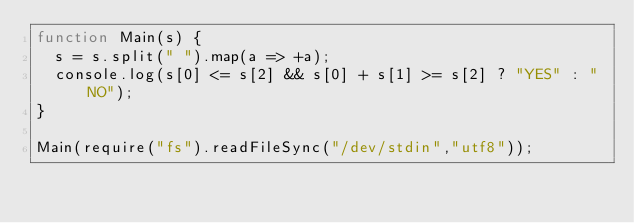<code> <loc_0><loc_0><loc_500><loc_500><_JavaScript_>function Main(s) {
  s = s.split(" ").map(a => +a);
  console.log(s[0] <= s[2] && s[0] + s[1] >= s[2] ? "YES" : "NO");
}

Main(require("fs").readFileSync("/dev/stdin","utf8"));</code> 